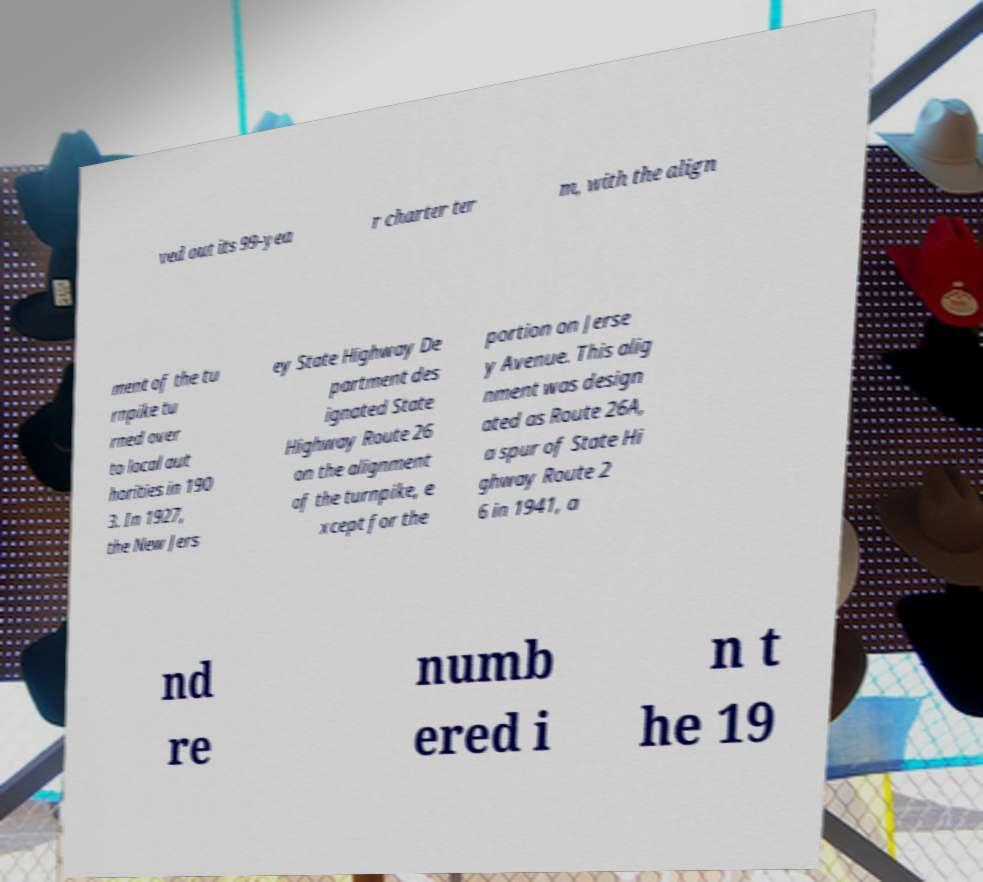Can you read and provide the text displayed in the image?This photo seems to have some interesting text. Can you extract and type it out for me? ved out its 99-yea r charter ter m, with the align ment of the tu rnpike tu rned over to local aut horities in 190 3. In 1927, the New Jers ey State Highway De partment des ignated State Highway Route 26 on the alignment of the turnpike, e xcept for the portion on Jerse y Avenue. This alig nment was design ated as Route 26A, a spur of State Hi ghway Route 2 6 in 1941, a nd re numb ered i n t he 19 